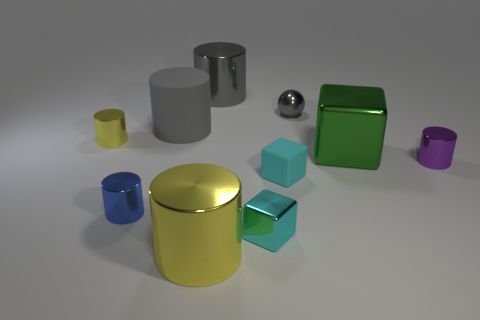Is there anything else that has the same color as the big matte thing?
Make the answer very short. Yes. What is the shape of the tiny blue object that is the same material as the tiny yellow object?
Provide a short and direct response. Cylinder. Do the tiny matte cube and the small sphere have the same color?
Give a very brief answer. No. Is the gray object that is right of the large gray shiny object made of the same material as the cylinder that is behind the big matte thing?
Your answer should be very brief. Yes. How many things are either tiny shiny cubes or metallic blocks that are in front of the purple metallic thing?
Your response must be concise. 1. Is there any other thing that has the same material as the big yellow object?
Your answer should be very brief. Yes. The object that is the same color as the matte cube is what shape?
Provide a short and direct response. Cube. What is the material of the sphere?
Keep it short and to the point. Metal. Does the ball have the same material as the small yellow cylinder?
Make the answer very short. Yes. What number of metallic objects are either gray cylinders or small things?
Give a very brief answer. 6. 